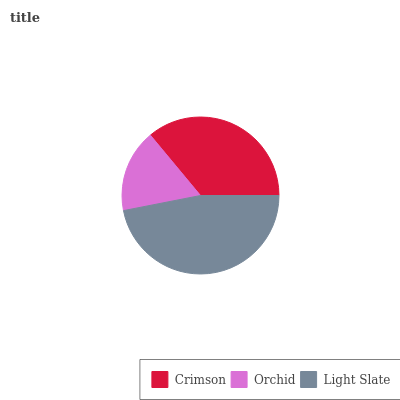Is Orchid the minimum?
Answer yes or no. Yes. Is Light Slate the maximum?
Answer yes or no. Yes. Is Light Slate the minimum?
Answer yes or no. No. Is Orchid the maximum?
Answer yes or no. No. Is Light Slate greater than Orchid?
Answer yes or no. Yes. Is Orchid less than Light Slate?
Answer yes or no. Yes. Is Orchid greater than Light Slate?
Answer yes or no. No. Is Light Slate less than Orchid?
Answer yes or no. No. Is Crimson the high median?
Answer yes or no. Yes. Is Crimson the low median?
Answer yes or no. Yes. Is Orchid the high median?
Answer yes or no. No. Is Orchid the low median?
Answer yes or no. No. 